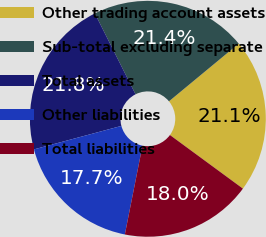<chart> <loc_0><loc_0><loc_500><loc_500><pie_chart><fcel>Other trading account assets<fcel>Sub-total excluding separate<fcel>Total assets<fcel>Other liabilities<fcel>Total liabilities<nl><fcel>21.08%<fcel>21.42%<fcel>21.76%<fcel>17.7%<fcel>18.04%<nl></chart> 